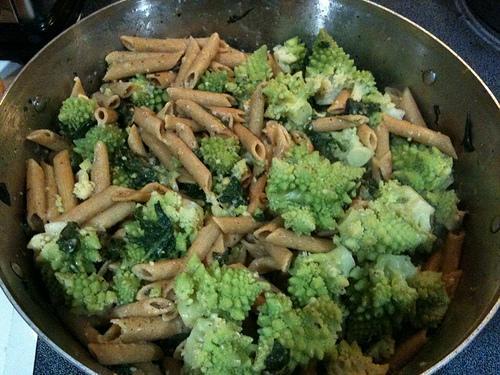How many broccolis can you see?
Give a very brief answer. 5. 